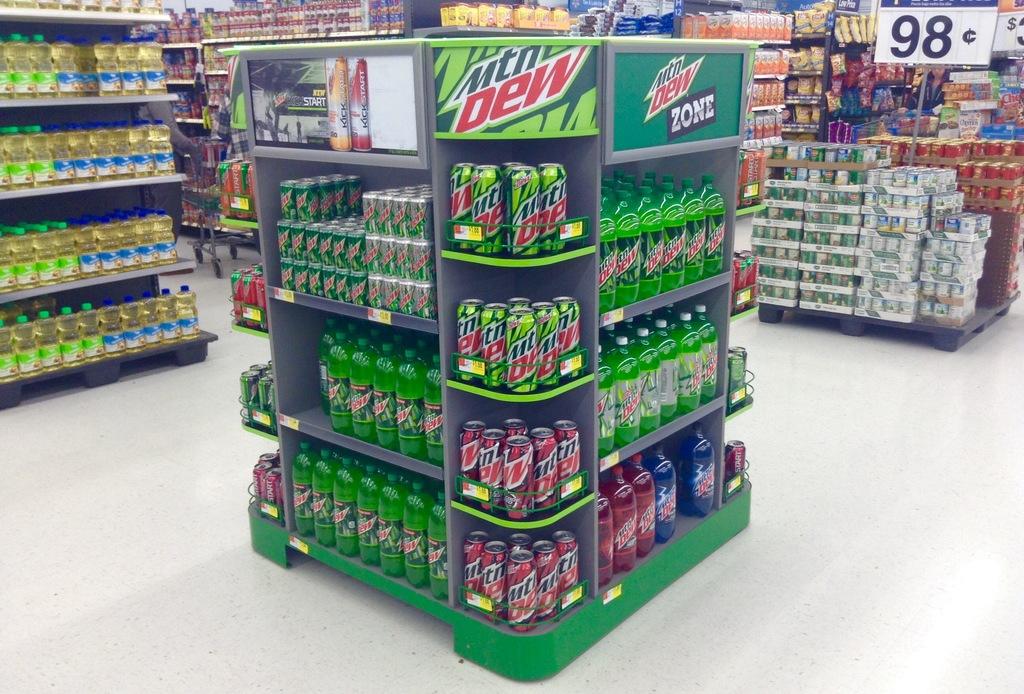What drink brand is this?
Provide a short and direct response. Mountain dew. How much are the items on the end cap?
Ensure brevity in your answer.  98 cents. 